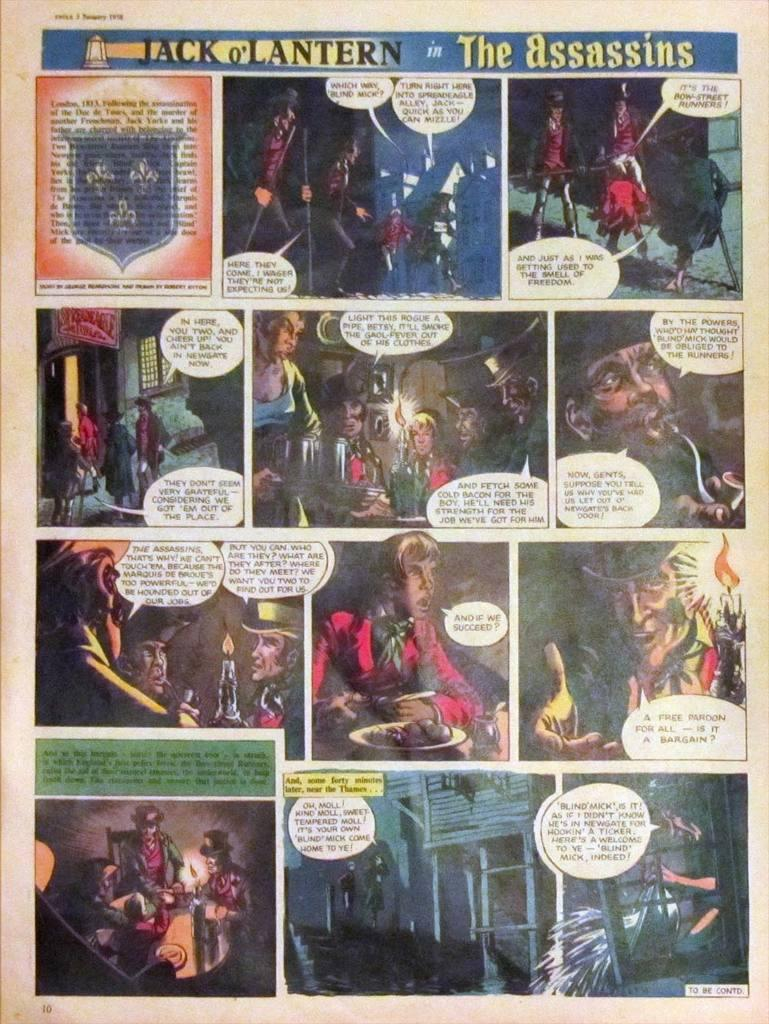Provide a one-sentence caption for the provided image. The comic was titled, "Jack o' Lantern in the Assassins.". 